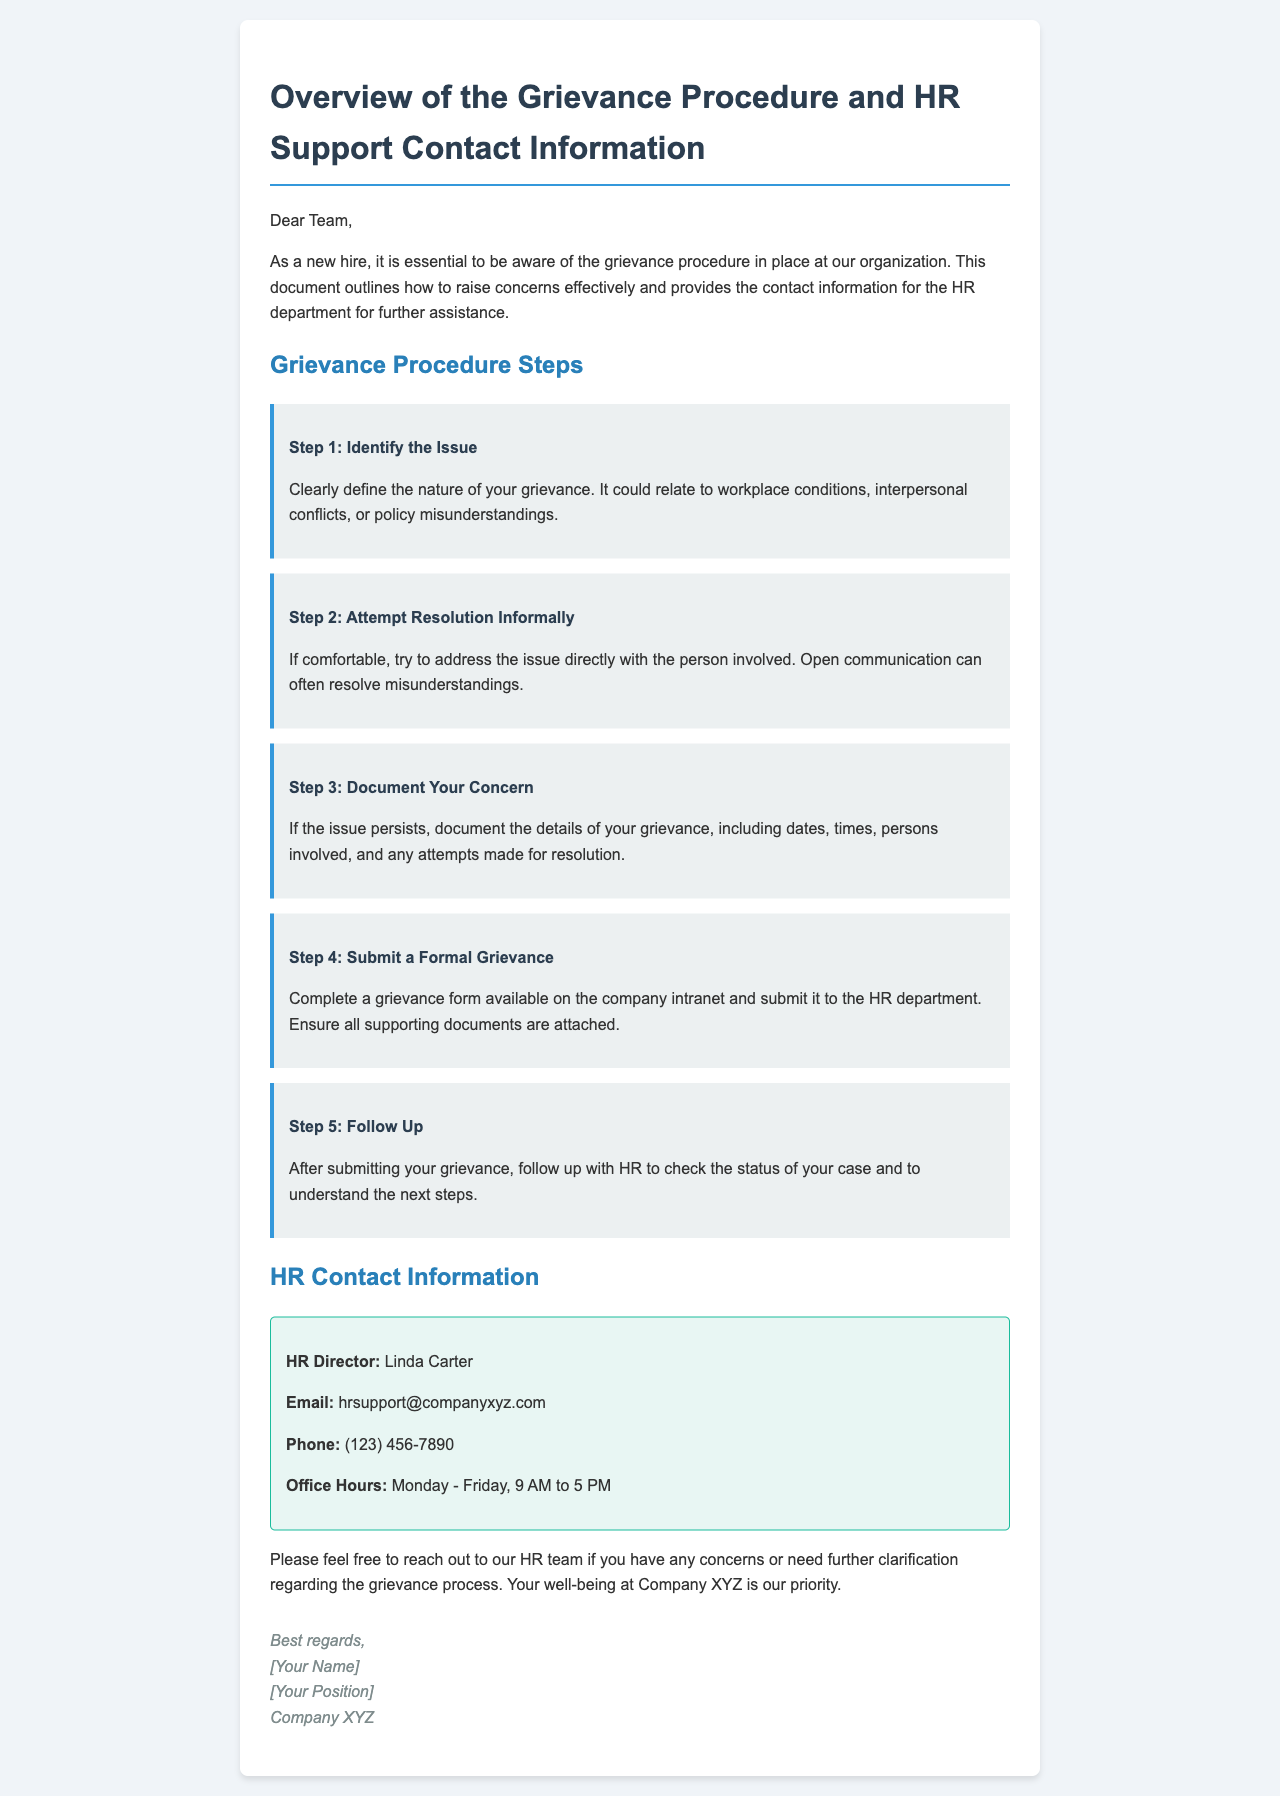what is the name of the HR Director? The HR Director's name is mentioned in the contact information section.
Answer: Linda Carter what is the email address for HR support? The email address for HR support is provided in the HR contact information.
Answer: hrsupport@companyxyz.com what are the office hours for HR? The office hours of HR are specified clearly in the document.
Answer: Monday - Friday, 9 AM to 5 PM how many steps are in the grievance procedure? The document lists the steps in the grievance procedure, which can be counted.
Answer: 5 what should you do if the issue persists after attempting informal resolution? The document outlines what to document if an informal resolution doesn't work.
Answer: Document the details of your grievance what is the first step in the grievance procedure? The first step is explicitly stated in the grievance procedure steps.
Answer: Identify the Issue why is it important to document your concern? Understanding is gained from the reasoning about what happens next in the grievance process.
Answer: To support your formal grievance submission what is the purpose of this email? The purpose is highlighted in the opening paragraph of the email.
Answer: To outline the grievance procedure and provide HR contact information 